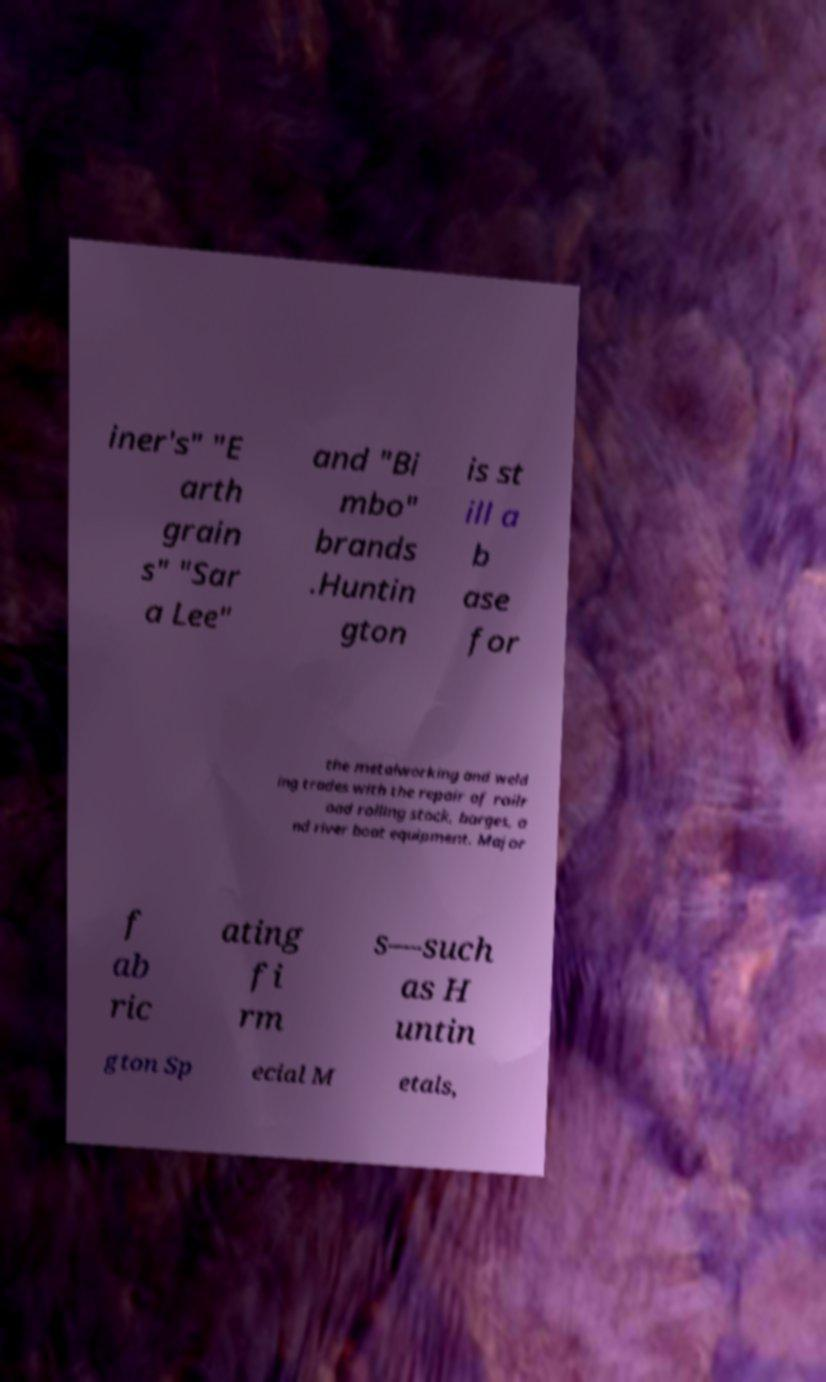There's text embedded in this image that I need extracted. Can you transcribe it verbatim? iner's" "E arth grain s" "Sar a Lee" and "Bi mbo" brands .Huntin gton is st ill a b ase for the metalworking and weld ing trades with the repair of railr oad rolling stock, barges, a nd river boat equipment. Major f ab ric ating fi rm s—such as H untin gton Sp ecial M etals, 